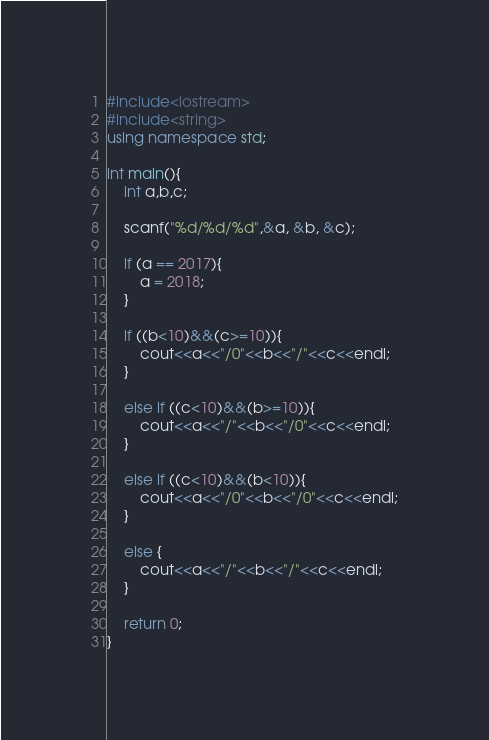<code> <loc_0><loc_0><loc_500><loc_500><_C++_>#include<iostream>
#include<string>
using namespace std;

int main(){
    int a,b,c;

    scanf("%d/%d/%d",&a, &b, &c);

    if (a == 2017){
        a = 2018;
    }

    if ((b<10)&&(c>=10)){
        cout<<a<<"/0"<<b<<"/"<<c<<endl;
    }

    else if ((c<10)&&(b>=10)){
        cout<<a<<"/"<<b<<"/0"<<c<<endl;
    }

    else if ((c<10)&&(b<10)){
        cout<<a<<"/0"<<b<<"/0"<<c<<endl;
    }

    else {
        cout<<a<<"/"<<b<<"/"<<c<<endl;
    }

    return 0;
}</code> 